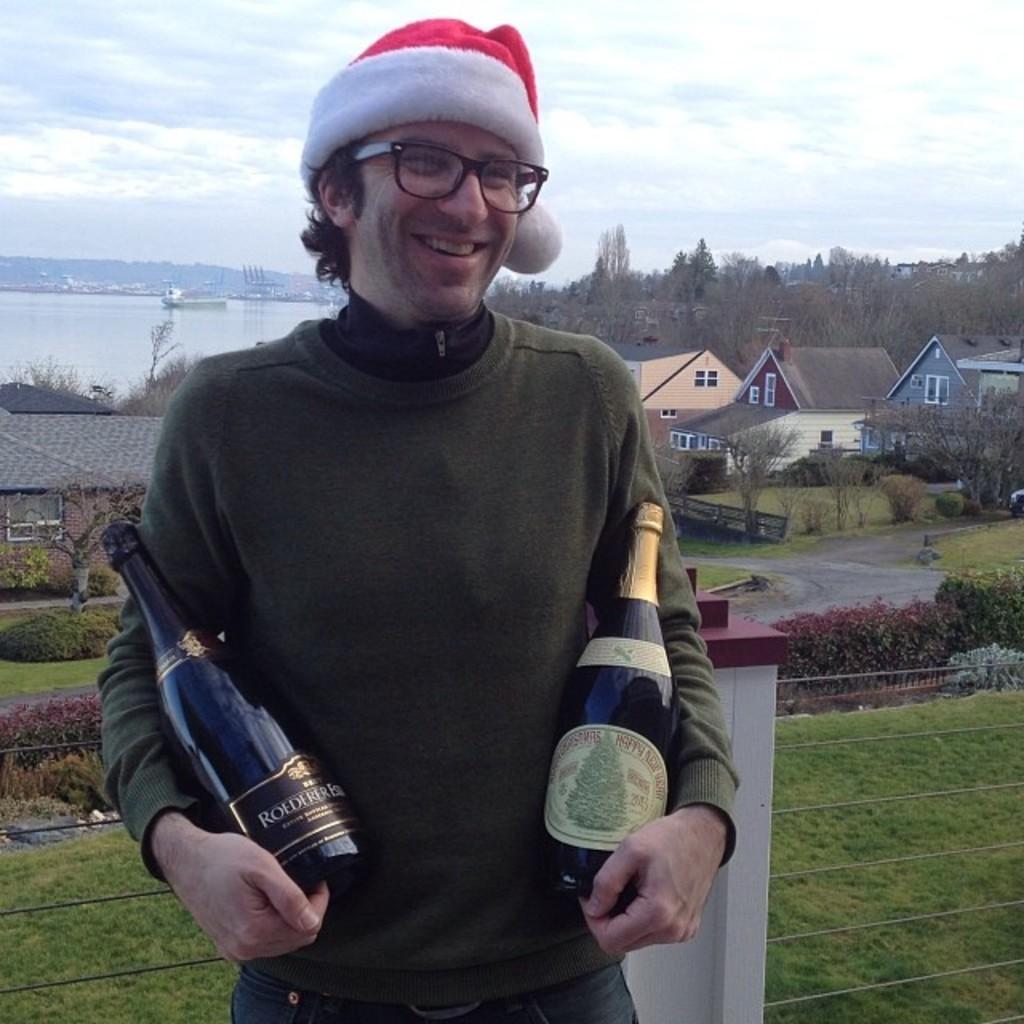In one or two sentences, can you explain what this image depicts? In this picture I can see a man standing and holding couple of bottles in his hands and he is wearing a cap on his head and I can see plants, trees, buildings and I can see water and a blue cloudy sky in the background. 